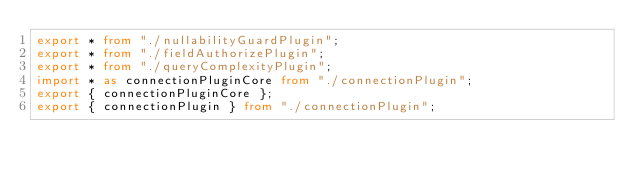Convert code to text. <code><loc_0><loc_0><loc_500><loc_500><_TypeScript_>export * from "./nullabilityGuardPlugin";
export * from "./fieldAuthorizePlugin";
export * from "./queryComplexityPlugin";
import * as connectionPluginCore from "./connectionPlugin";
export { connectionPluginCore };
export { connectionPlugin } from "./connectionPlugin";
</code> 